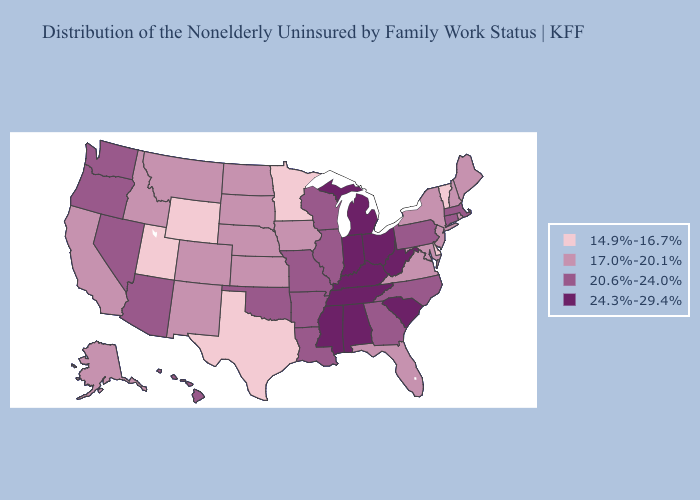Does Virginia have the lowest value in the USA?
Be succinct. No. Does New York have the lowest value in the Northeast?
Answer briefly. No. Among the states that border Iowa , does Minnesota have the lowest value?
Give a very brief answer. Yes. Does the map have missing data?
Answer briefly. No. Does Colorado have the lowest value in the West?
Give a very brief answer. No. Is the legend a continuous bar?
Concise answer only. No. What is the value of Washington?
Be succinct. 20.6%-24.0%. Does North Dakota have the lowest value in the USA?
Be succinct. No. Name the states that have a value in the range 14.9%-16.7%?
Keep it brief. Delaware, Minnesota, Texas, Utah, Vermont, Wyoming. Does Florida have the same value as Alabama?
Concise answer only. No. Name the states that have a value in the range 17.0%-20.1%?
Concise answer only. Alaska, California, Colorado, Florida, Idaho, Iowa, Kansas, Maine, Maryland, Montana, Nebraska, New Hampshire, New Jersey, New Mexico, New York, North Dakota, Rhode Island, South Dakota, Virginia. Among the states that border Kansas , does Oklahoma have the highest value?
Short answer required. Yes. Does Georgia have a lower value than Louisiana?
Write a very short answer. No. Does North Dakota have the same value as Michigan?
Concise answer only. No. What is the highest value in states that border Wisconsin?
Quick response, please. 24.3%-29.4%. 